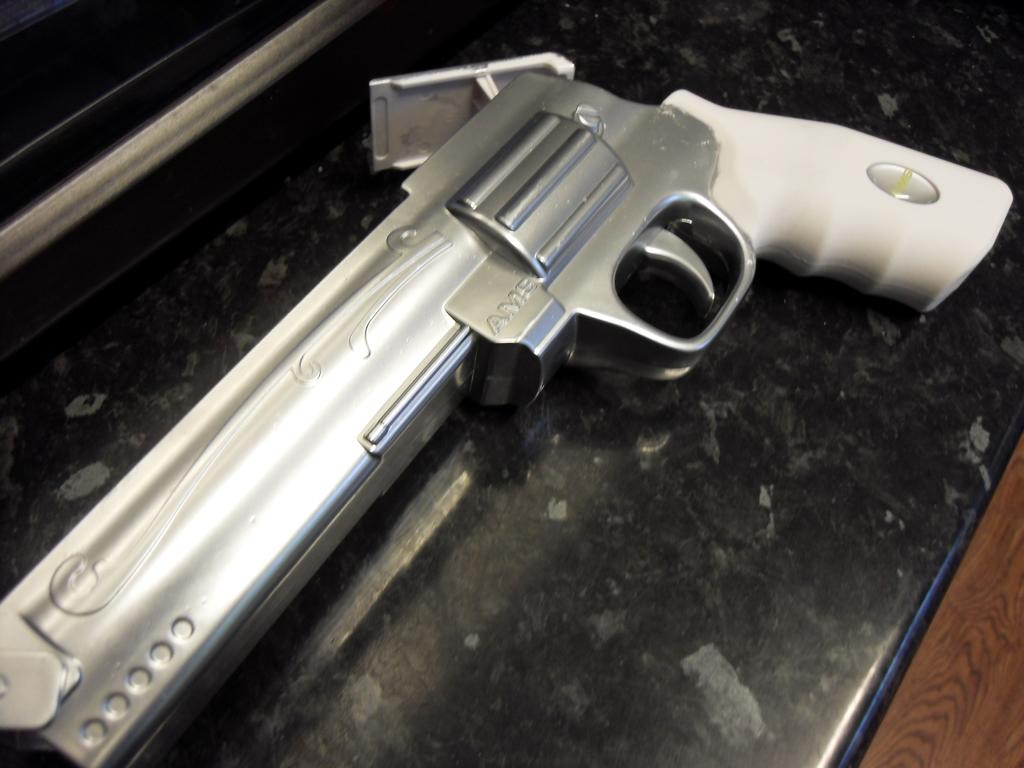What object is the main focus of the image? There is a gun in the image. Can you describe the color of the gun? The gun is white and grey in color. How does the gun appear in the image? The gun resembles a toy gun. How many weeks does the gun have in the image? The concept of weeks does not apply to a gun, as it is an inanimate object. 